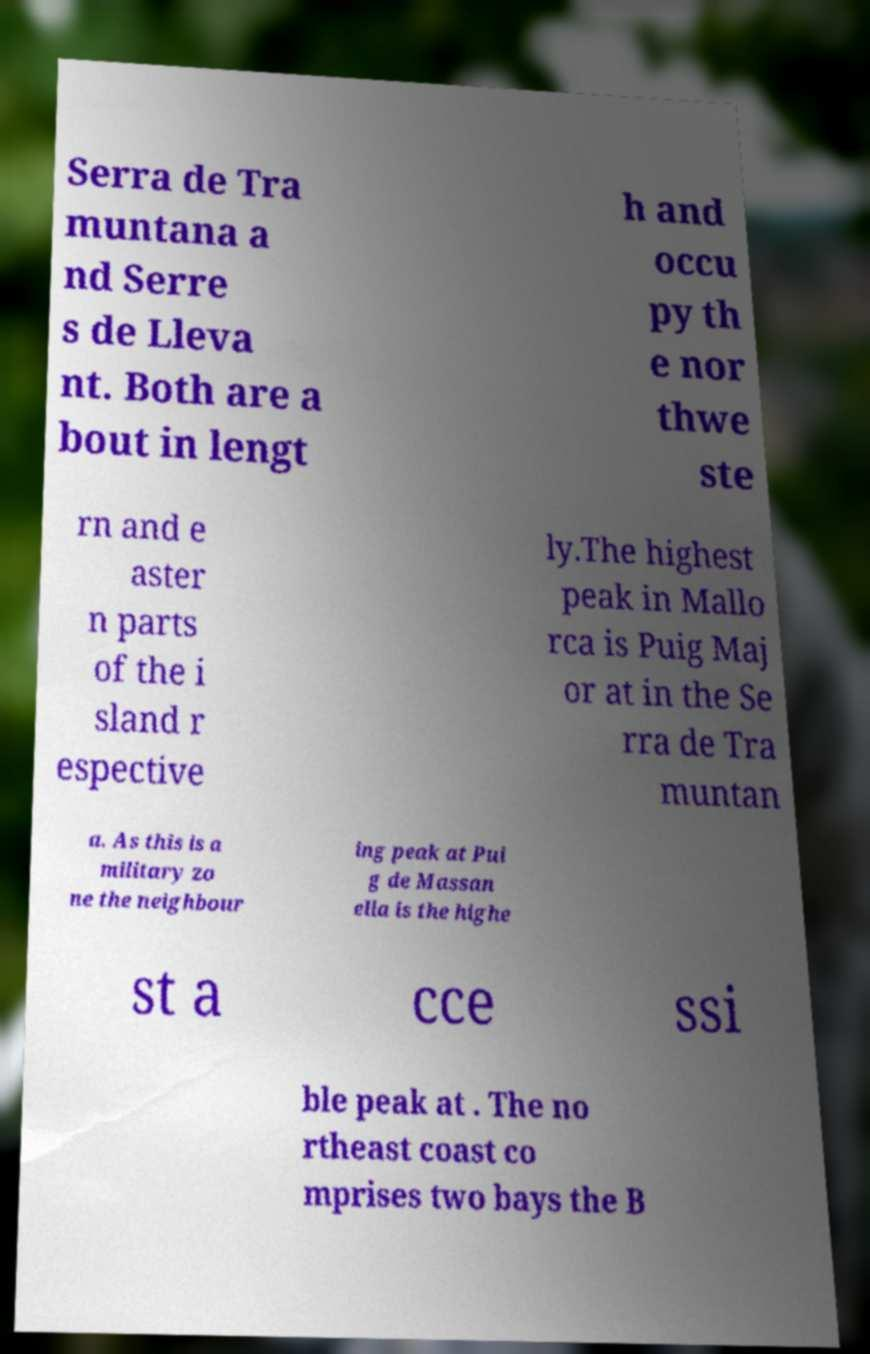There's text embedded in this image that I need extracted. Can you transcribe it verbatim? Serra de Tra muntana a nd Serre s de Lleva nt. Both are a bout in lengt h and occu py th e nor thwe ste rn and e aster n parts of the i sland r espective ly.The highest peak in Mallo rca is Puig Maj or at in the Se rra de Tra muntan a. As this is a military zo ne the neighbour ing peak at Pui g de Massan ella is the highe st a cce ssi ble peak at . The no rtheast coast co mprises two bays the B 